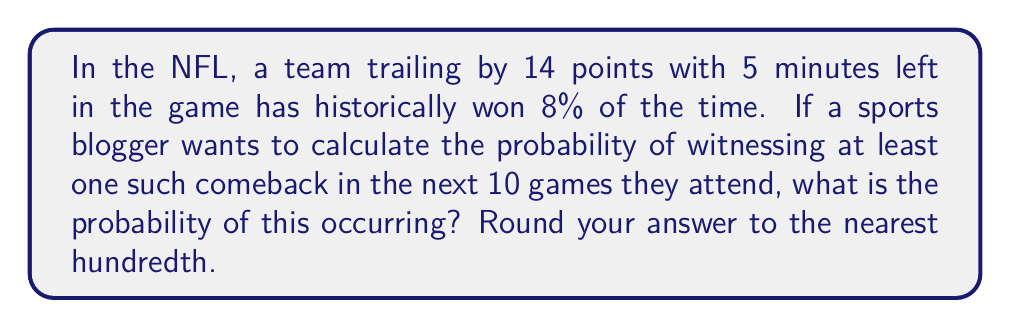Give your solution to this math problem. Let's approach this step-by-step:

1) First, we need to find the probability of not seeing a comeback in a single game. If the probability of a comeback is 8% or 0.08, then the probability of not seeing a comeback is:

   $1 - 0.08 = 0.92$ or 92%

2) Now, we want to calculate the probability of not seeing a comeback in all 10 games. Since each game is independent, we multiply these probabilities:

   $0.92^{10} = 0.4341$ or about 43.41%

3) This 0.4341 represents the probability of not seeing any comebacks in 10 games. But we want the probability of seeing at least one comeback. This is the opposite event, so we subtract from 1:

   $1 - 0.4341 = 0.5659$

4) Converting to a percentage and rounding to the nearest hundredth:

   $0.5659 \times 100 \approx 56.59\%$

This can also be expressed using the binomial probability formula:

$$P(\text{at least one comeback}) = 1 - P(\text{no comebacks})$$
$$= 1 - \binom{10}{0}(0.08)^0(0.92)^{10}$$
$$= 1 - (0.92)^{10}$$
$$\approx 0.5659$$
Answer: 56.59% 